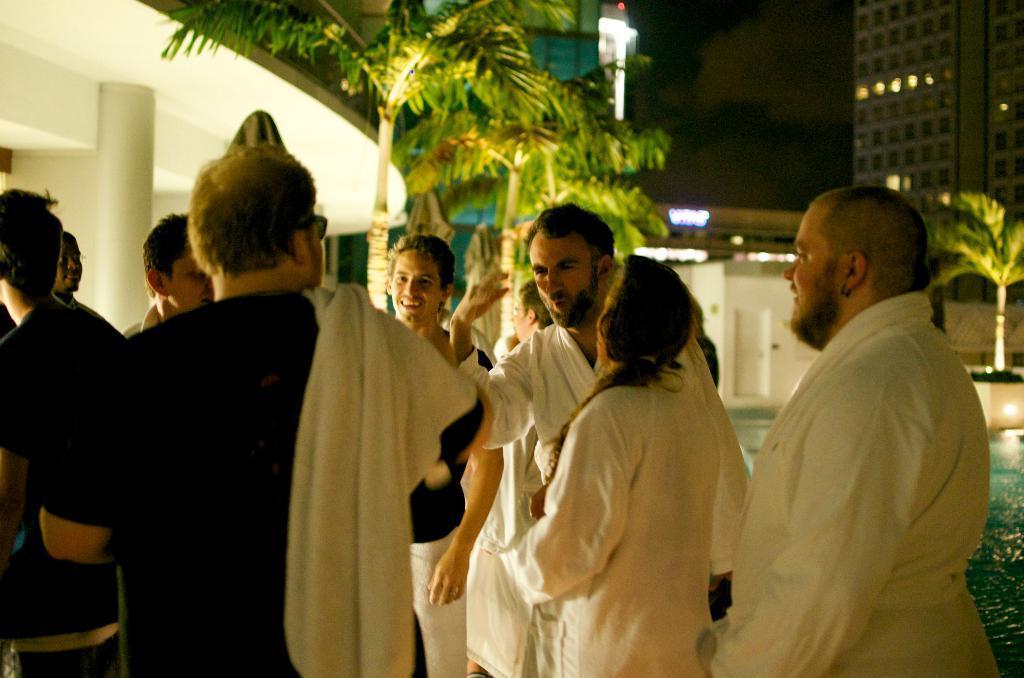Please provide a concise description of this image. In the foreground of the picture there are people standing. On the right there is a swimming pool. In the center of the picture there are palm trees. The background is blurred. In the background there are buildings. On the left there is a building. 